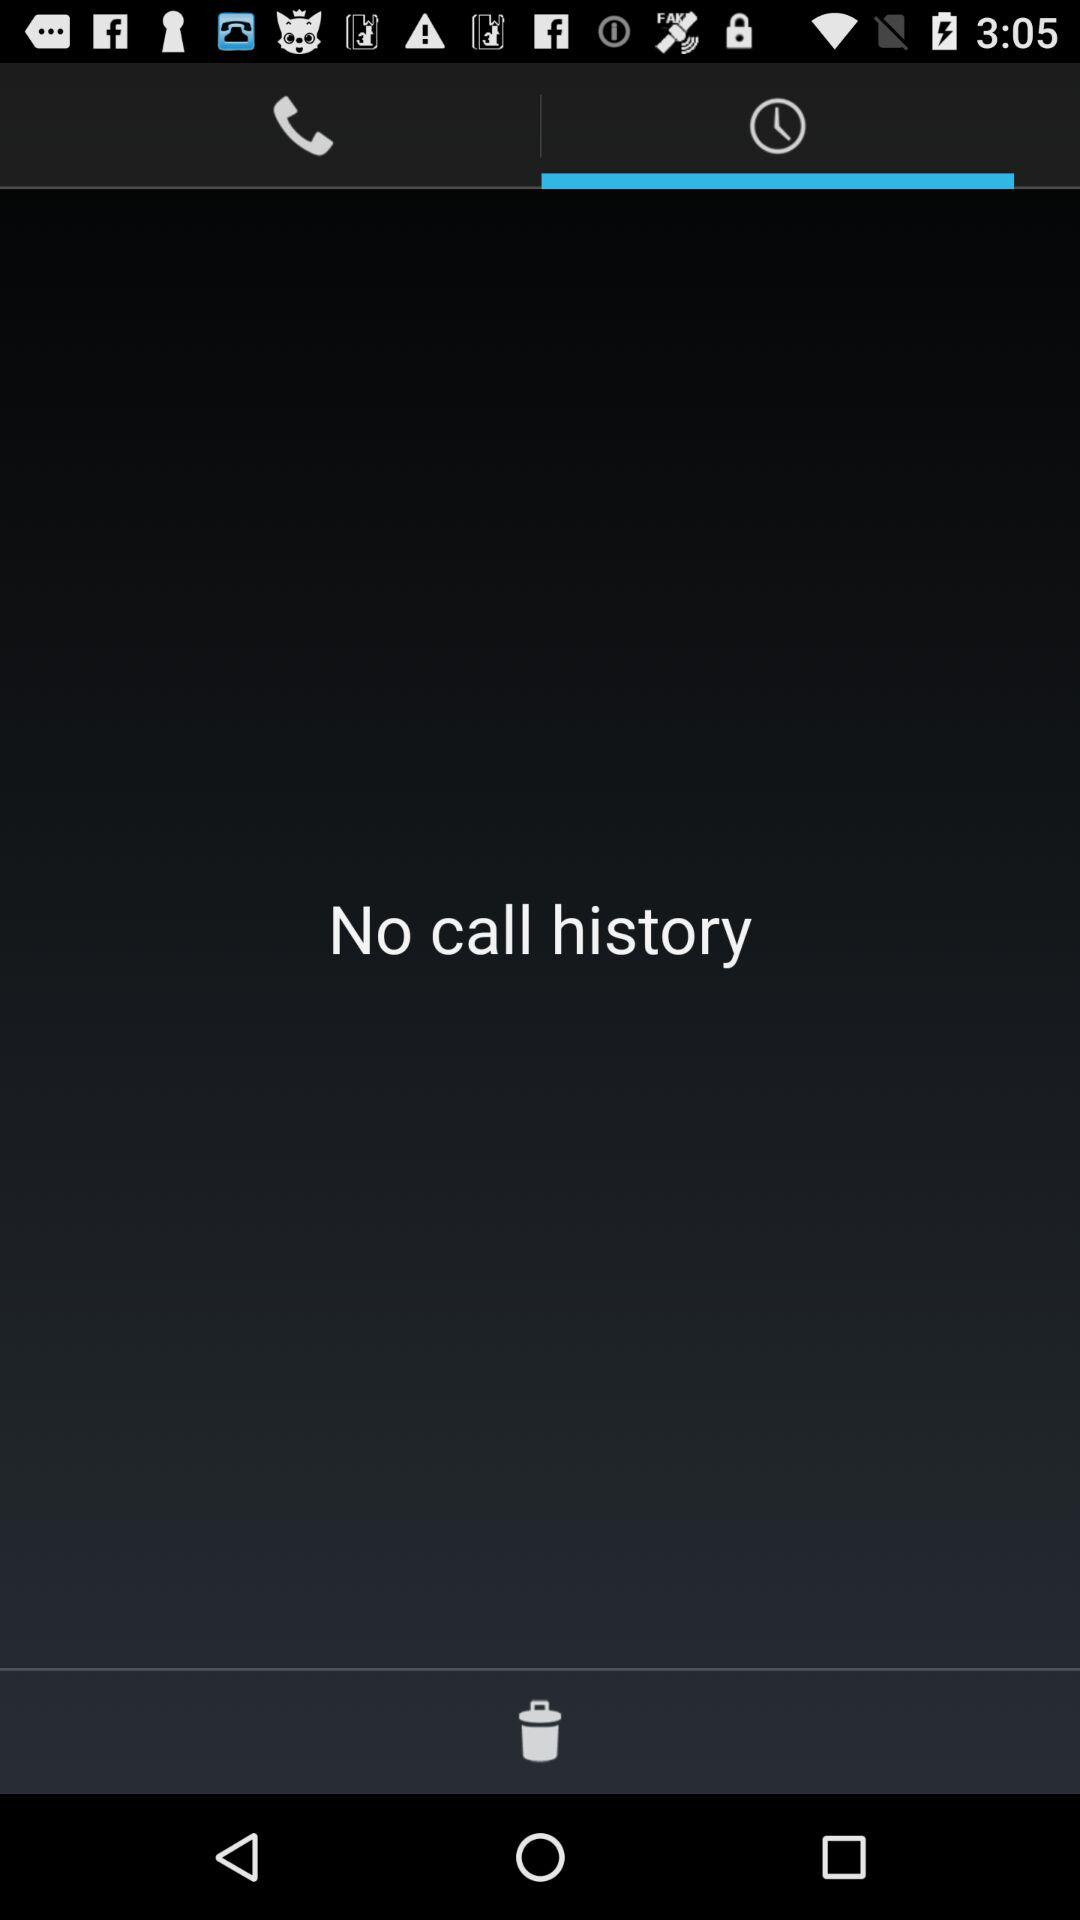How many call history items are displayed?
Answer the question using a single word or phrase. 0 